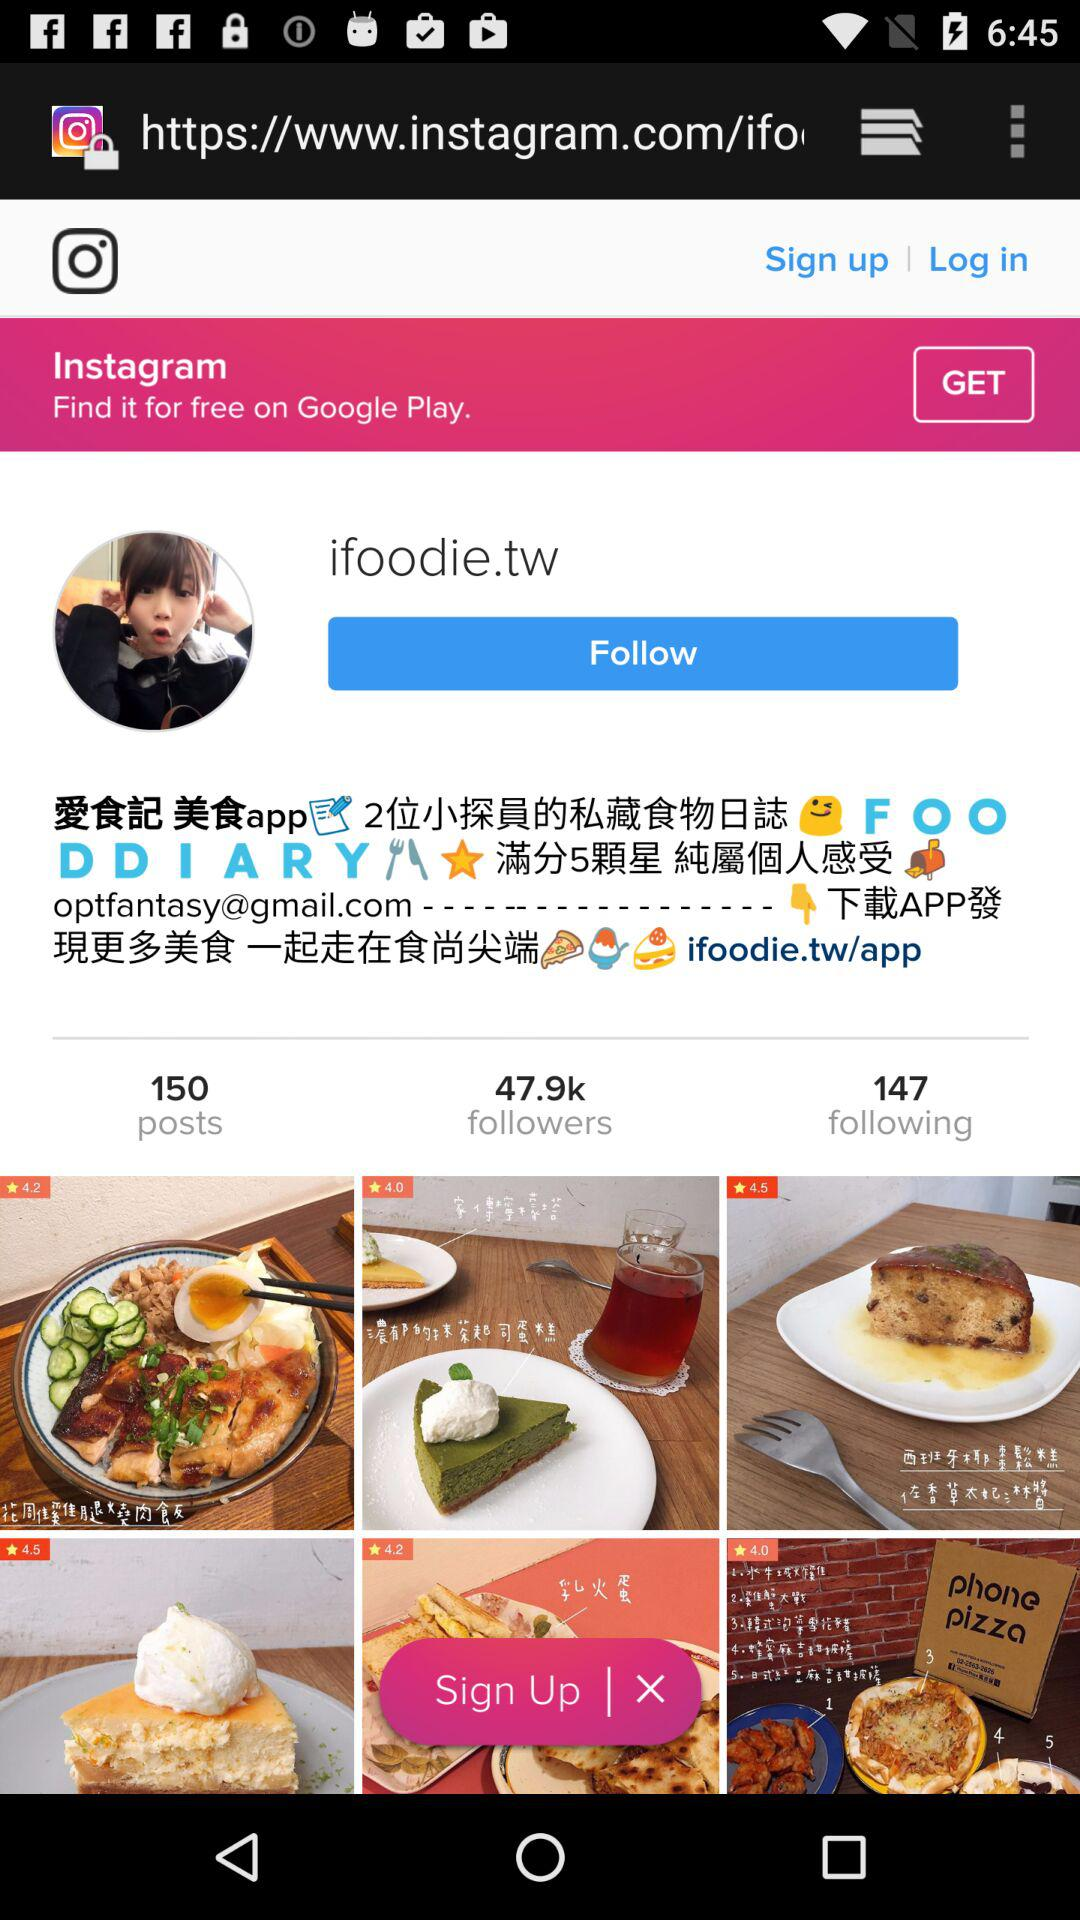How many followers are on the account? There are 47.9k followers. 